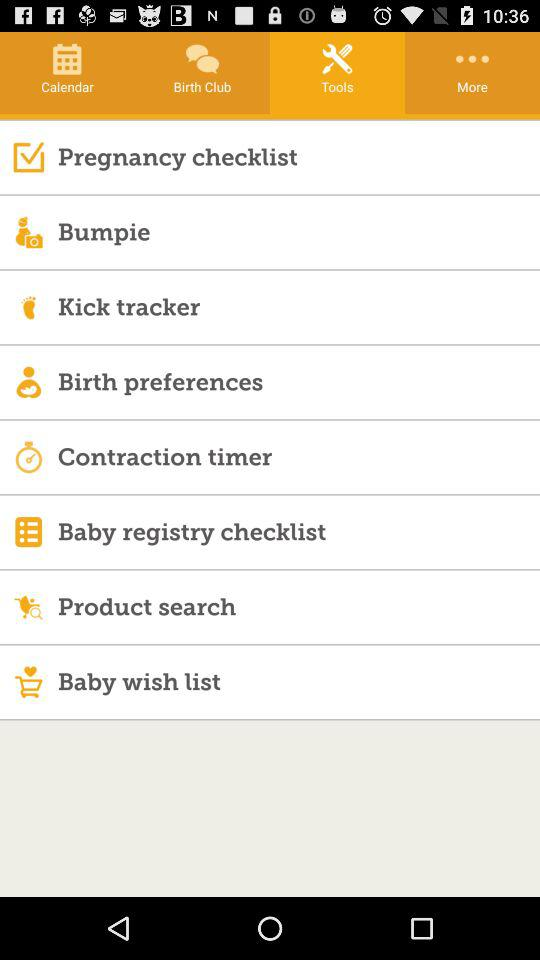Which is the selected tab? The selected tab is "Tools". 